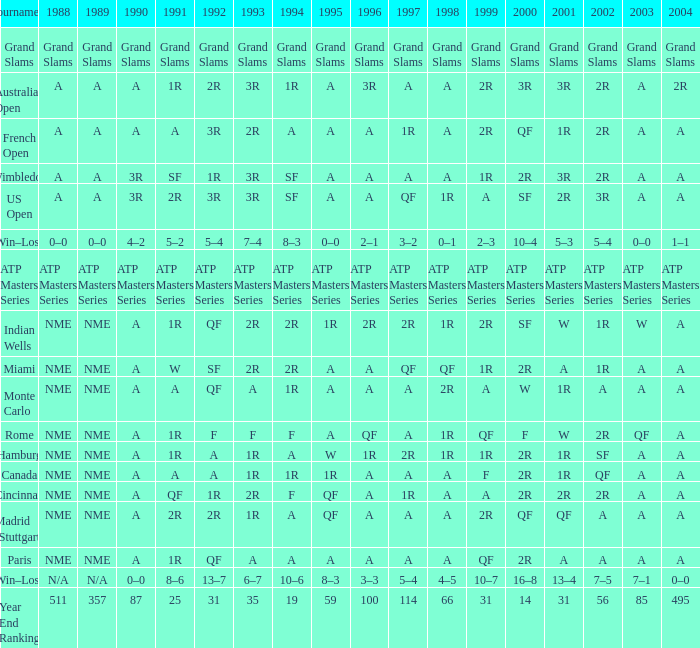What shows for 1992 when 2001 is 1r, 1994 is 1r, and the 2002 is qf? A. 